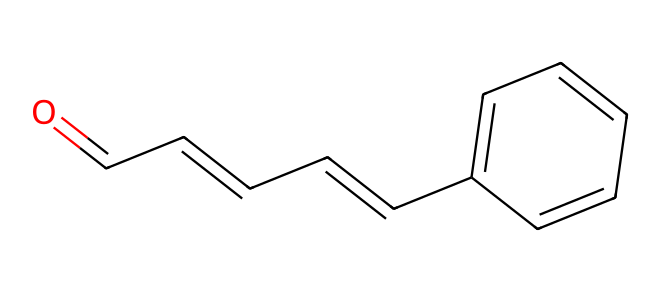What is the name of this chemical? The primary structure depicted corresponds to a known compound used in various applications, which is widely recognized as cinnamaldehyde.
Answer: cinnamaldehyde How many carbon atoms are in the structure? By counting the carbon atoms in the given SMILES representation, there are ten carbon atoms present in the structure.
Answer: 10 What type of functional group is present in cinnamaldehyde? The structure contains a carbonyl group (C=O), which is characteristic of aldehydes, indicating the presence of an aldehyde functional group.
Answer: aldehyde What is the total number of double bonds in cinnamaldehyde? Upon analyzing the structure, there are three double bonds present: one in the carbonyl group and two in the carbon chain (C=C).
Answer: 3 What is the longest carbon chain in the structure? The longest continuous chain of carbon atoms consists of six carbons, which includes the carbonyl carbon and extends through the alkene part.
Answer: 6 How many hydrogen atoms are attached to the molecule? Considering the valency of carbon and the structure presented, there are ten hydrogen atoms bonded to the carbon atoms in this aldehyde.
Answer: 10 Which ring structure is part of this compound? In the chemical structure, there is a benzene ring, indicated by the alternating double bonds surrounding the six-membered carbon ring part of the molecule.
Answer: benzene 